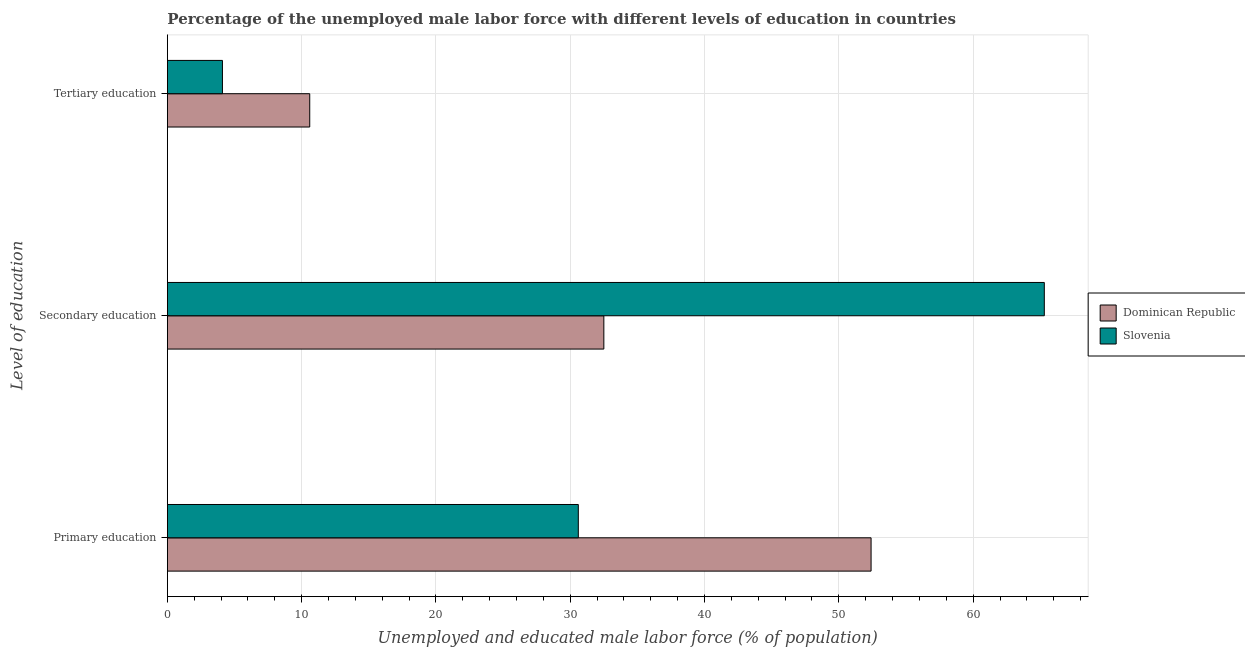How many different coloured bars are there?
Make the answer very short. 2. How many groups of bars are there?
Make the answer very short. 3. Are the number of bars per tick equal to the number of legend labels?
Provide a succinct answer. Yes. How many bars are there on the 1st tick from the top?
Provide a succinct answer. 2. What is the label of the 2nd group of bars from the top?
Ensure brevity in your answer.  Secondary education. What is the percentage of male labor force who received primary education in Dominican Republic?
Offer a terse response. 52.4. Across all countries, what is the maximum percentage of male labor force who received primary education?
Your response must be concise. 52.4. Across all countries, what is the minimum percentage of male labor force who received tertiary education?
Your answer should be very brief. 4.1. In which country was the percentage of male labor force who received tertiary education maximum?
Keep it short and to the point. Dominican Republic. In which country was the percentage of male labor force who received tertiary education minimum?
Ensure brevity in your answer.  Slovenia. What is the total percentage of male labor force who received tertiary education in the graph?
Provide a succinct answer. 14.7. What is the difference between the percentage of male labor force who received primary education in Dominican Republic and that in Slovenia?
Provide a short and direct response. 21.8. What is the difference between the percentage of male labor force who received tertiary education in Slovenia and the percentage of male labor force who received secondary education in Dominican Republic?
Offer a terse response. -28.4. What is the average percentage of male labor force who received secondary education per country?
Your response must be concise. 48.9. What is the difference between the percentage of male labor force who received secondary education and percentage of male labor force who received primary education in Dominican Republic?
Offer a terse response. -19.9. What is the ratio of the percentage of male labor force who received secondary education in Dominican Republic to that in Slovenia?
Your answer should be compact. 0.5. What is the difference between the highest and the second highest percentage of male labor force who received tertiary education?
Offer a terse response. 6.5. What is the difference between the highest and the lowest percentage of male labor force who received primary education?
Your answer should be very brief. 21.8. Is the sum of the percentage of male labor force who received primary education in Slovenia and Dominican Republic greater than the maximum percentage of male labor force who received tertiary education across all countries?
Give a very brief answer. Yes. What does the 2nd bar from the top in Secondary education represents?
Provide a succinct answer. Dominican Republic. What does the 1st bar from the bottom in Secondary education represents?
Make the answer very short. Dominican Republic. How many countries are there in the graph?
Your answer should be compact. 2. What is the difference between two consecutive major ticks on the X-axis?
Provide a short and direct response. 10. Are the values on the major ticks of X-axis written in scientific E-notation?
Your answer should be very brief. No. Does the graph contain any zero values?
Your answer should be very brief. No. Where does the legend appear in the graph?
Your answer should be compact. Center right. How many legend labels are there?
Ensure brevity in your answer.  2. What is the title of the graph?
Ensure brevity in your answer.  Percentage of the unemployed male labor force with different levels of education in countries. What is the label or title of the X-axis?
Offer a very short reply. Unemployed and educated male labor force (% of population). What is the label or title of the Y-axis?
Your answer should be compact. Level of education. What is the Unemployed and educated male labor force (% of population) of Dominican Republic in Primary education?
Offer a terse response. 52.4. What is the Unemployed and educated male labor force (% of population) in Slovenia in Primary education?
Your answer should be very brief. 30.6. What is the Unemployed and educated male labor force (% of population) of Dominican Republic in Secondary education?
Offer a very short reply. 32.5. What is the Unemployed and educated male labor force (% of population) of Slovenia in Secondary education?
Offer a terse response. 65.3. What is the Unemployed and educated male labor force (% of population) of Dominican Republic in Tertiary education?
Your response must be concise. 10.6. What is the Unemployed and educated male labor force (% of population) of Slovenia in Tertiary education?
Provide a short and direct response. 4.1. Across all Level of education, what is the maximum Unemployed and educated male labor force (% of population) of Dominican Republic?
Provide a short and direct response. 52.4. Across all Level of education, what is the maximum Unemployed and educated male labor force (% of population) of Slovenia?
Your response must be concise. 65.3. Across all Level of education, what is the minimum Unemployed and educated male labor force (% of population) in Dominican Republic?
Ensure brevity in your answer.  10.6. Across all Level of education, what is the minimum Unemployed and educated male labor force (% of population) in Slovenia?
Give a very brief answer. 4.1. What is the total Unemployed and educated male labor force (% of population) of Dominican Republic in the graph?
Your answer should be very brief. 95.5. What is the difference between the Unemployed and educated male labor force (% of population) of Dominican Republic in Primary education and that in Secondary education?
Provide a short and direct response. 19.9. What is the difference between the Unemployed and educated male labor force (% of population) in Slovenia in Primary education and that in Secondary education?
Provide a succinct answer. -34.7. What is the difference between the Unemployed and educated male labor force (% of population) of Dominican Republic in Primary education and that in Tertiary education?
Offer a very short reply. 41.8. What is the difference between the Unemployed and educated male labor force (% of population) in Dominican Republic in Secondary education and that in Tertiary education?
Give a very brief answer. 21.9. What is the difference between the Unemployed and educated male labor force (% of population) in Slovenia in Secondary education and that in Tertiary education?
Keep it short and to the point. 61.2. What is the difference between the Unemployed and educated male labor force (% of population) of Dominican Republic in Primary education and the Unemployed and educated male labor force (% of population) of Slovenia in Secondary education?
Offer a terse response. -12.9. What is the difference between the Unemployed and educated male labor force (% of population) of Dominican Republic in Primary education and the Unemployed and educated male labor force (% of population) of Slovenia in Tertiary education?
Your answer should be very brief. 48.3. What is the difference between the Unemployed and educated male labor force (% of population) in Dominican Republic in Secondary education and the Unemployed and educated male labor force (% of population) in Slovenia in Tertiary education?
Your answer should be compact. 28.4. What is the average Unemployed and educated male labor force (% of population) of Dominican Republic per Level of education?
Your answer should be very brief. 31.83. What is the average Unemployed and educated male labor force (% of population) of Slovenia per Level of education?
Offer a very short reply. 33.33. What is the difference between the Unemployed and educated male labor force (% of population) in Dominican Republic and Unemployed and educated male labor force (% of population) in Slovenia in Primary education?
Your answer should be compact. 21.8. What is the difference between the Unemployed and educated male labor force (% of population) in Dominican Republic and Unemployed and educated male labor force (% of population) in Slovenia in Secondary education?
Your answer should be very brief. -32.8. What is the difference between the Unemployed and educated male labor force (% of population) of Dominican Republic and Unemployed and educated male labor force (% of population) of Slovenia in Tertiary education?
Offer a terse response. 6.5. What is the ratio of the Unemployed and educated male labor force (% of population) of Dominican Republic in Primary education to that in Secondary education?
Offer a very short reply. 1.61. What is the ratio of the Unemployed and educated male labor force (% of population) in Slovenia in Primary education to that in Secondary education?
Provide a succinct answer. 0.47. What is the ratio of the Unemployed and educated male labor force (% of population) in Dominican Republic in Primary education to that in Tertiary education?
Provide a succinct answer. 4.94. What is the ratio of the Unemployed and educated male labor force (% of population) in Slovenia in Primary education to that in Tertiary education?
Your answer should be compact. 7.46. What is the ratio of the Unemployed and educated male labor force (% of population) in Dominican Republic in Secondary education to that in Tertiary education?
Your answer should be compact. 3.07. What is the ratio of the Unemployed and educated male labor force (% of population) of Slovenia in Secondary education to that in Tertiary education?
Provide a short and direct response. 15.93. What is the difference between the highest and the second highest Unemployed and educated male labor force (% of population) in Dominican Republic?
Make the answer very short. 19.9. What is the difference between the highest and the second highest Unemployed and educated male labor force (% of population) of Slovenia?
Your response must be concise. 34.7. What is the difference between the highest and the lowest Unemployed and educated male labor force (% of population) in Dominican Republic?
Make the answer very short. 41.8. What is the difference between the highest and the lowest Unemployed and educated male labor force (% of population) in Slovenia?
Make the answer very short. 61.2. 